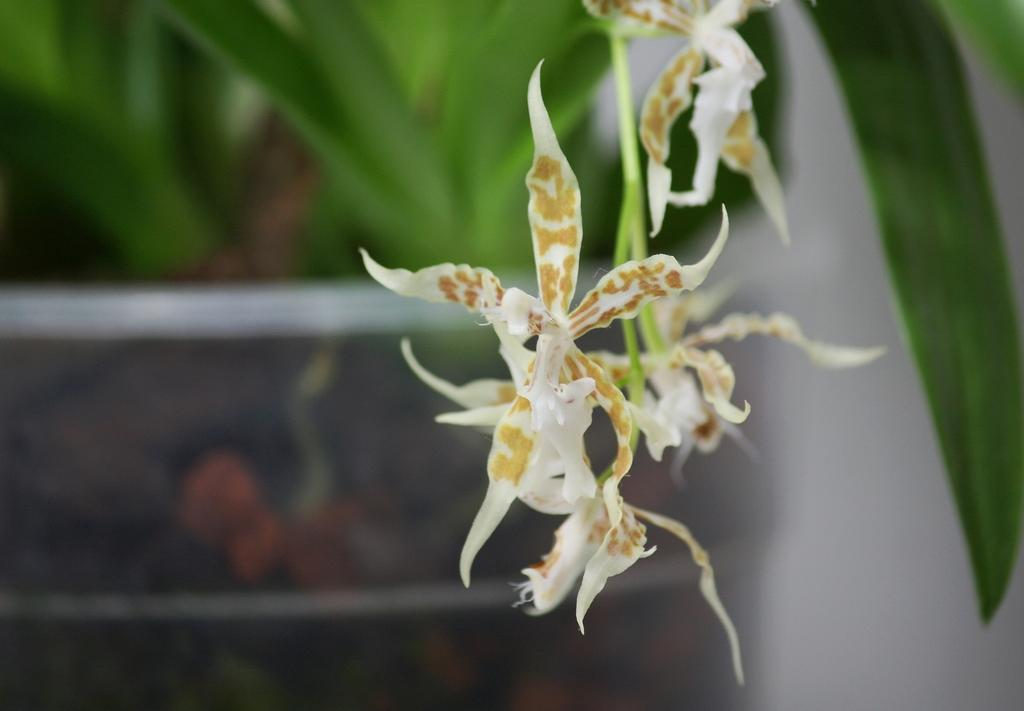What can be seen in the foreground of the image? There are flowers and stems in the foreground of the image. What type of vegetation is visible in the background of the image? There is greenery in the background of the image. What type of needle is being used by the uncle in the image? There is no uncle or needle present in the image. 